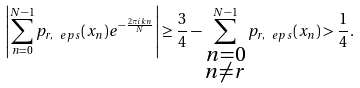Convert formula to latex. <formula><loc_0><loc_0><loc_500><loc_500>\left | \sum _ { n = 0 } ^ { N - 1 } p _ { r , \ e p s } ( x _ { n } ) e ^ { - \frac { 2 \pi i k n } { N } } \right | \geq \frac { 3 } { 4 } - \sum _ { \substack { n = 0 \\ n \neq r } } ^ { N - 1 } p _ { r , \ e p s } ( x _ { n } ) > \frac { 1 } { 4 } .</formula> 